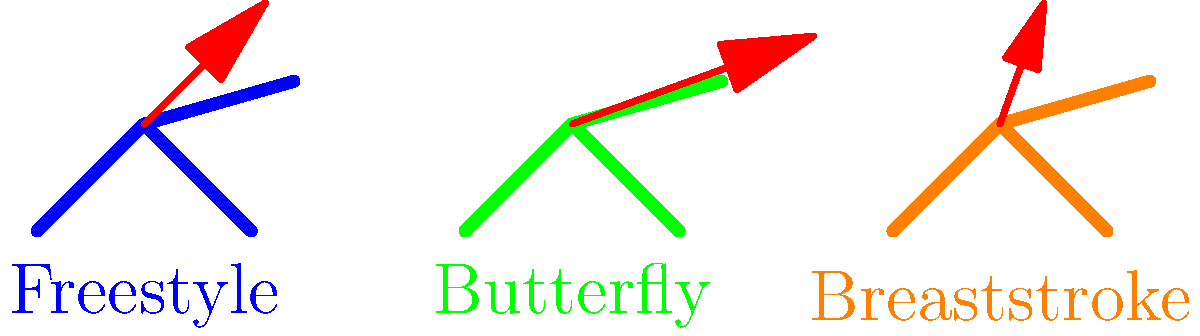Based on the vector diagrams representing torque generated in different swimming strokes, which stroke produces the greatest torque during the arm pull phase? To determine which swimming stroke produces the greatest torque during the arm pull phase, we need to analyze the vector diagrams provided:

1. Freestyle (blue swimmer):
   - Torque vector angle: approximately 45°
   - Torque vector magnitude: 0.8 units

2. Butterfly (green swimmer):
   - Torque vector angle: approximately 20°
   - Torque vector magnitude: 1.2 units

3. Breaststroke (orange swimmer):
   - Torque vector angle: approximately 70°
   - Torque vector magnitude: 0.6 units

Torque is a measure of the rotational force applied and is represented by the length of the red arrow in each diagram. The longer the arrow, the greater the torque.

Comparing the magnitudes:
- Freestyle: 0.8 units
- Butterfly: 1.2 units
- Breaststroke: 0.6 units

The Butterfly stroke has the longest torque vector (1.2 units), indicating that it produces the greatest torque during the arm pull phase among the three strokes shown.

It's important to note that the angle of the torque vector also plays a role in the effectiveness of the stroke, but for this comparison, we are focusing solely on the magnitude of the torque generated.
Answer: Butterfly 